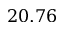<formula> <loc_0><loc_0><loc_500><loc_500>2 0 . 7 6</formula> 